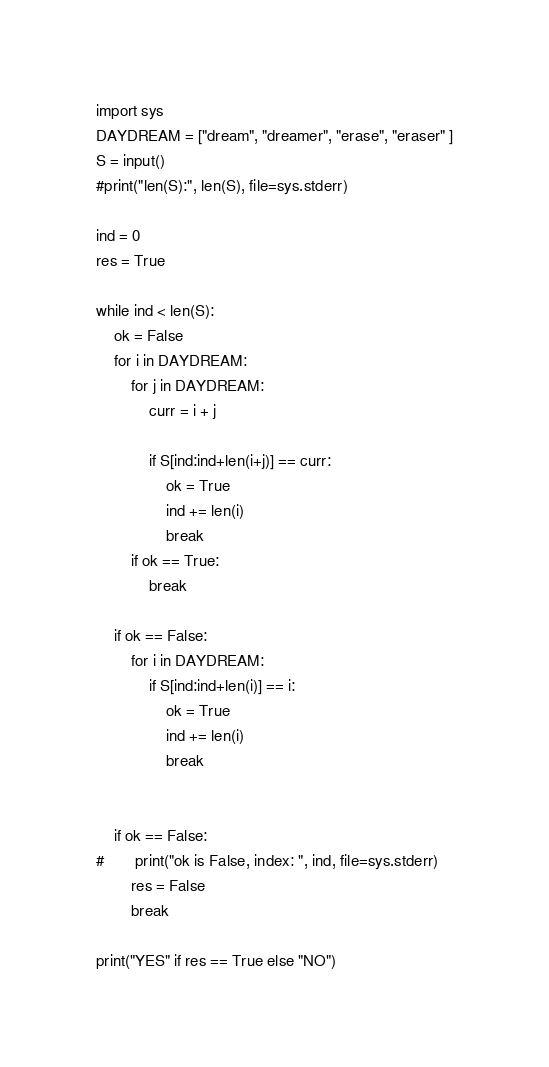Convert code to text. <code><loc_0><loc_0><loc_500><loc_500><_Python_>import sys
DAYDREAM = ["dream", "dreamer", "erase", "eraser" ]
S = input()
#print("len(S):", len(S), file=sys.stderr)

ind = 0
res = True

while ind < len(S):
	ok = False
	for i in DAYDREAM:
		for j in DAYDREAM:
			curr = i + j
			
			if S[ind:ind+len(i+j)] == curr:
				ok = True
				ind += len(i)
				break
		if ok == True:
			break

	if ok == False:
		for i in DAYDREAM:
			if S[ind:ind+len(i)] == i:
				ok = True
				ind += len(i)
				break


	if ok == False:
#		print("ok is False, index: ", ind, file=sys.stderr)
		res = False
		break

print("YES" if res == True else "NO")	</code> 